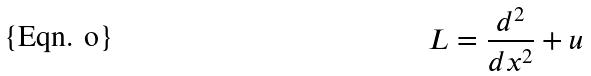Convert formula to latex. <formula><loc_0><loc_0><loc_500><loc_500>L = \frac { d ^ { 2 } } { d x ^ { 2 } } + u</formula> 